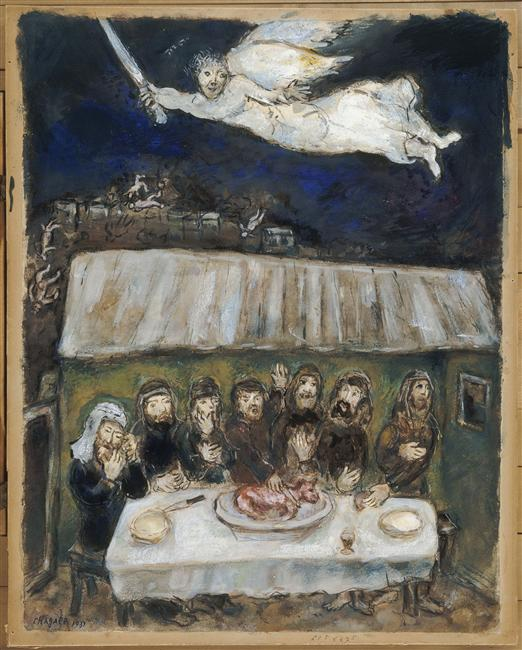Could the piece of meat on the table have a deeper meaning? Yes, the piece of meat on the table could symbolize sustenance, sacrifice, or a significant ritualistic offering. In various cultures, meat is often associated with feasts, communal gatherings, and religious ceremonies, suggesting that its presence in the image has thematic and symbolic importance. It could represent the provision of essential resources, a communal bond, or a sacrificial act meant to honor or appease a higher power. 